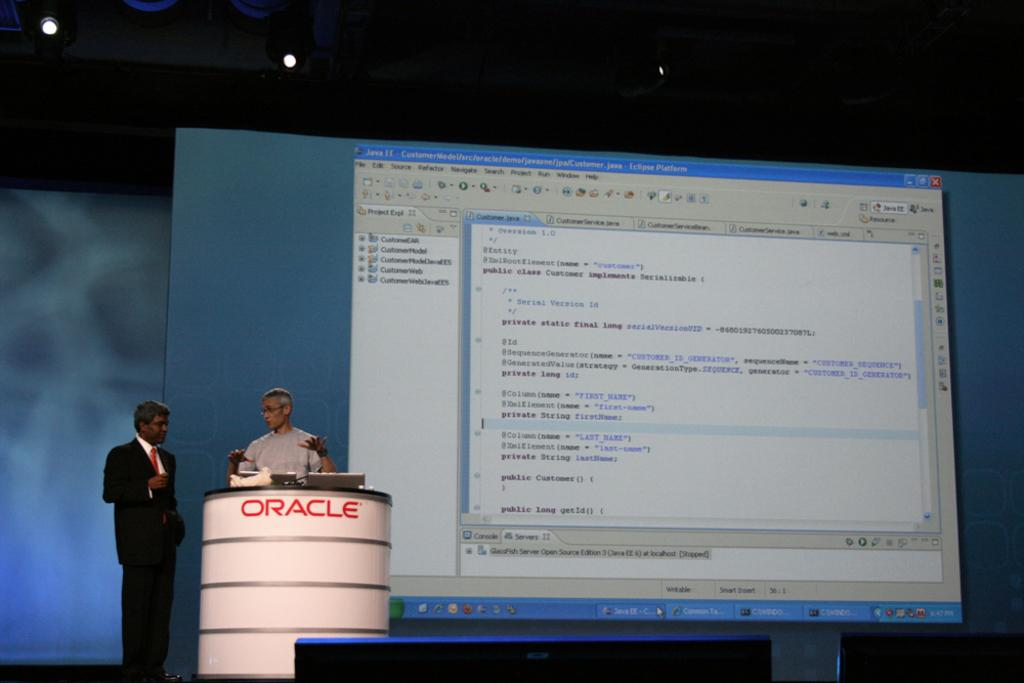<image>
Relay a brief, clear account of the picture shown. A person is giving a presentation at a podium that says "Oracle" on the front. 